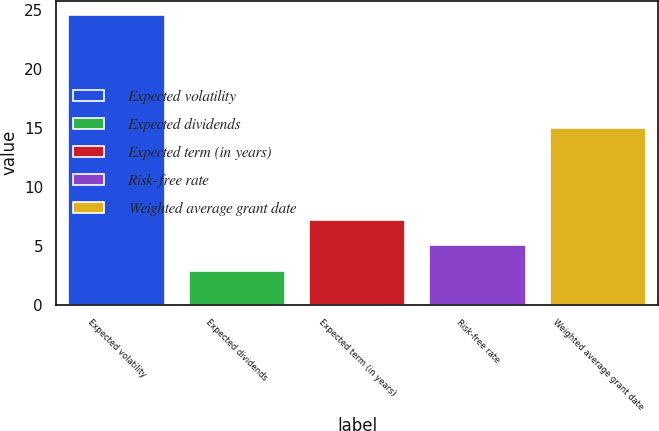Convert chart. <chart><loc_0><loc_0><loc_500><loc_500><bar_chart><fcel>Expected volatility<fcel>Expected dividends<fcel>Expected term (in years)<fcel>Risk-free rate<fcel>Weighted average grant date<nl><fcel>24.5<fcel>2.86<fcel>7.18<fcel>5.02<fcel>14.98<nl></chart> 